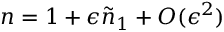Convert formula to latex. <formula><loc_0><loc_0><loc_500><loc_500>n = 1 + \epsilon \tilde { n } _ { 1 } + O ( \epsilon ^ { 2 } )</formula> 